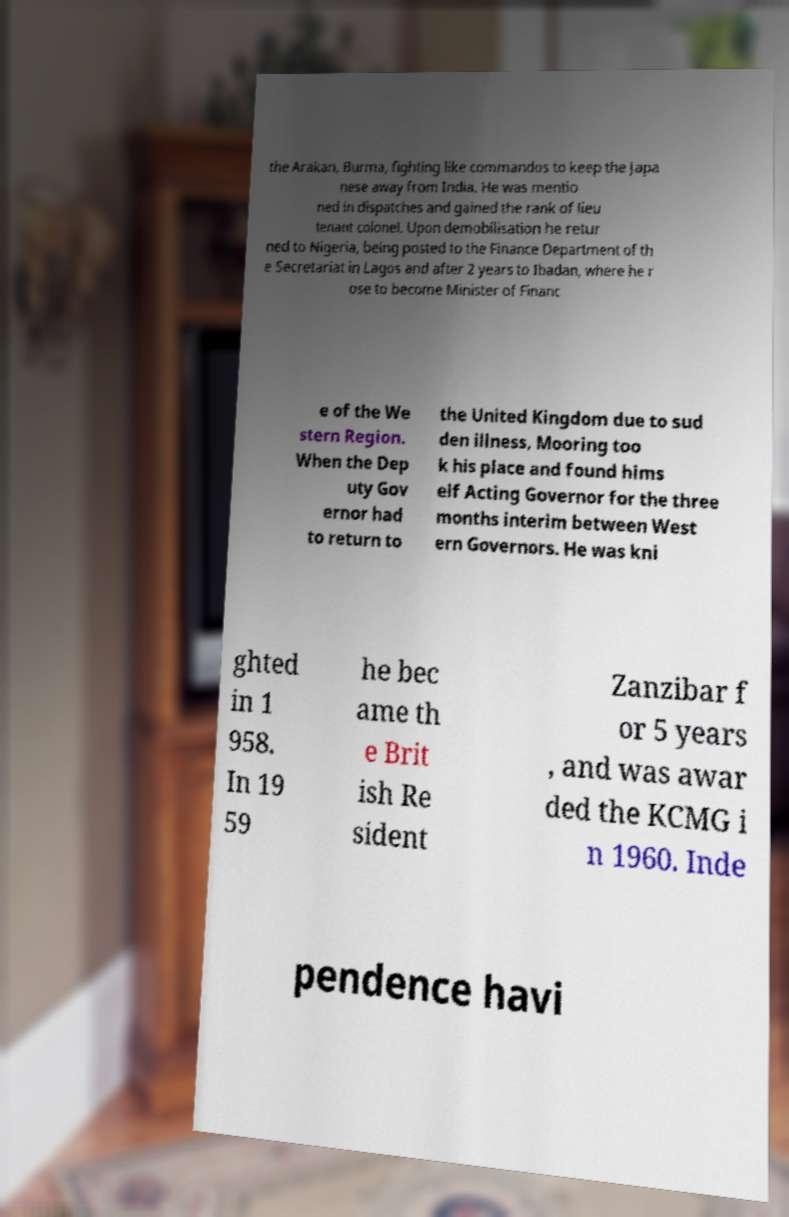Can you accurately transcribe the text from the provided image for me? the Arakan, Burma, fighting like commandos to keep the Japa nese away from India. He was mentio ned in dispatches and gained the rank of lieu tenant colonel. Upon demobilisation he retur ned to Nigeria, being posted to the Finance Department of th e Secretariat in Lagos and after 2 years to Ibadan, where he r ose to become Minister of Financ e of the We stern Region. When the Dep uty Gov ernor had to return to the United Kingdom due to sud den illness, Mooring too k his place and found hims elf Acting Governor for the three months interim between West ern Governors. He was kni ghted in 1 958. In 19 59 he bec ame th e Brit ish Re sident Zanzibar f or 5 years , and was awar ded the KCMG i n 1960. Inde pendence havi 